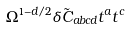<formula> <loc_0><loc_0><loc_500><loc_500>\Omega ^ { 1 - d / 2 } \delta \tilde { C } _ { a b c d } t ^ { a } t ^ { c }</formula> 